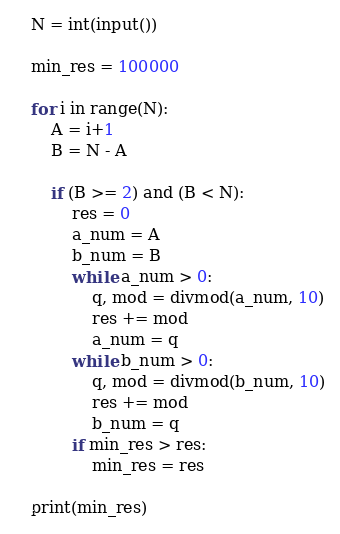<code> <loc_0><loc_0><loc_500><loc_500><_Python_>N = int(input())

min_res = 100000

for i in range(N):
    A = i+1
    B = N - A

    if (B >= 2) and (B < N):
        res = 0
        a_num = A
        b_num = B
        while a_num > 0:
            q, mod = divmod(a_num, 10)
            res += mod
            a_num = q
        while b_num > 0:
            q, mod = divmod(b_num, 10)
            res += mod
            b_num = q
        if min_res > res:
            min_res = res

print(min_res)
</code> 